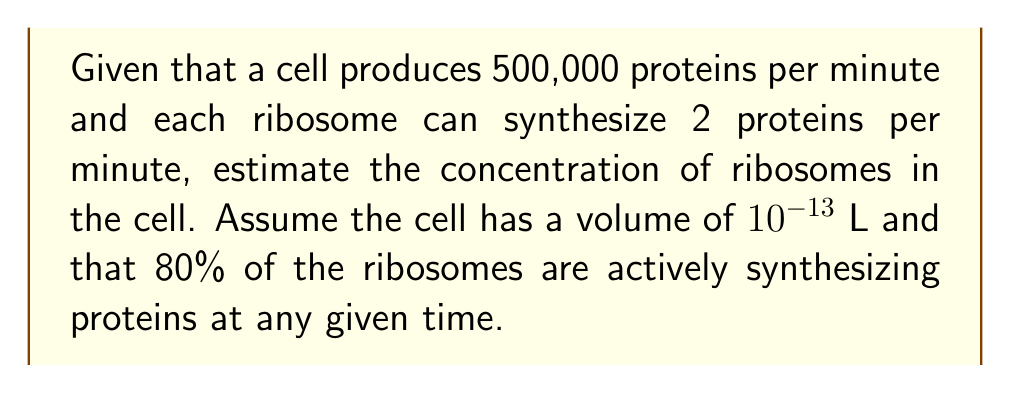Give your solution to this math problem. Let's approach this step-by-step:

1) First, we need to calculate the total number of active ribosomes:
   - Total proteins produced per minute = 500,000
   - Proteins produced per ribosome per minute = 2
   - Number of active ribosomes = $\frac{500,000}{2} = 250,000$

2) We're told that 80% of ribosomes are active, so to find the total number of ribosomes:
   - Let $x$ be the total number of ribosomes
   - $0.8x = 250,000$
   - $x = \frac{250,000}{0.8} = 312,500$ total ribosomes

3) Now we need to calculate the concentration. Concentration is typically measured in moles per liter (M).
   - Cell volume = $10^{-13}$ L
   - Number of ribosomes = 312,500

4) To convert to moles, we need to divide by Avogadro's number:
   $\text{Moles of ribosomes} = \frac{312,500}{6.022 \times 10^{23}} = 5.19 \times 10^{-19}$ mol

5) Now we can calculate the concentration:
   $$\text{Concentration} = \frac{\text{Moles}}{\text{Volume}} = \frac{5.19 \times 10^{-19} \text{ mol}}{10^{-13} \text{ L}} = 5.19 \times 10^{-6} \text{ M}$$

Thus, the estimated concentration of ribosomes in the cell is approximately $5.19 \times 10^{-6}$ M or 5.19 µM.
Answer: 5.19 µM 